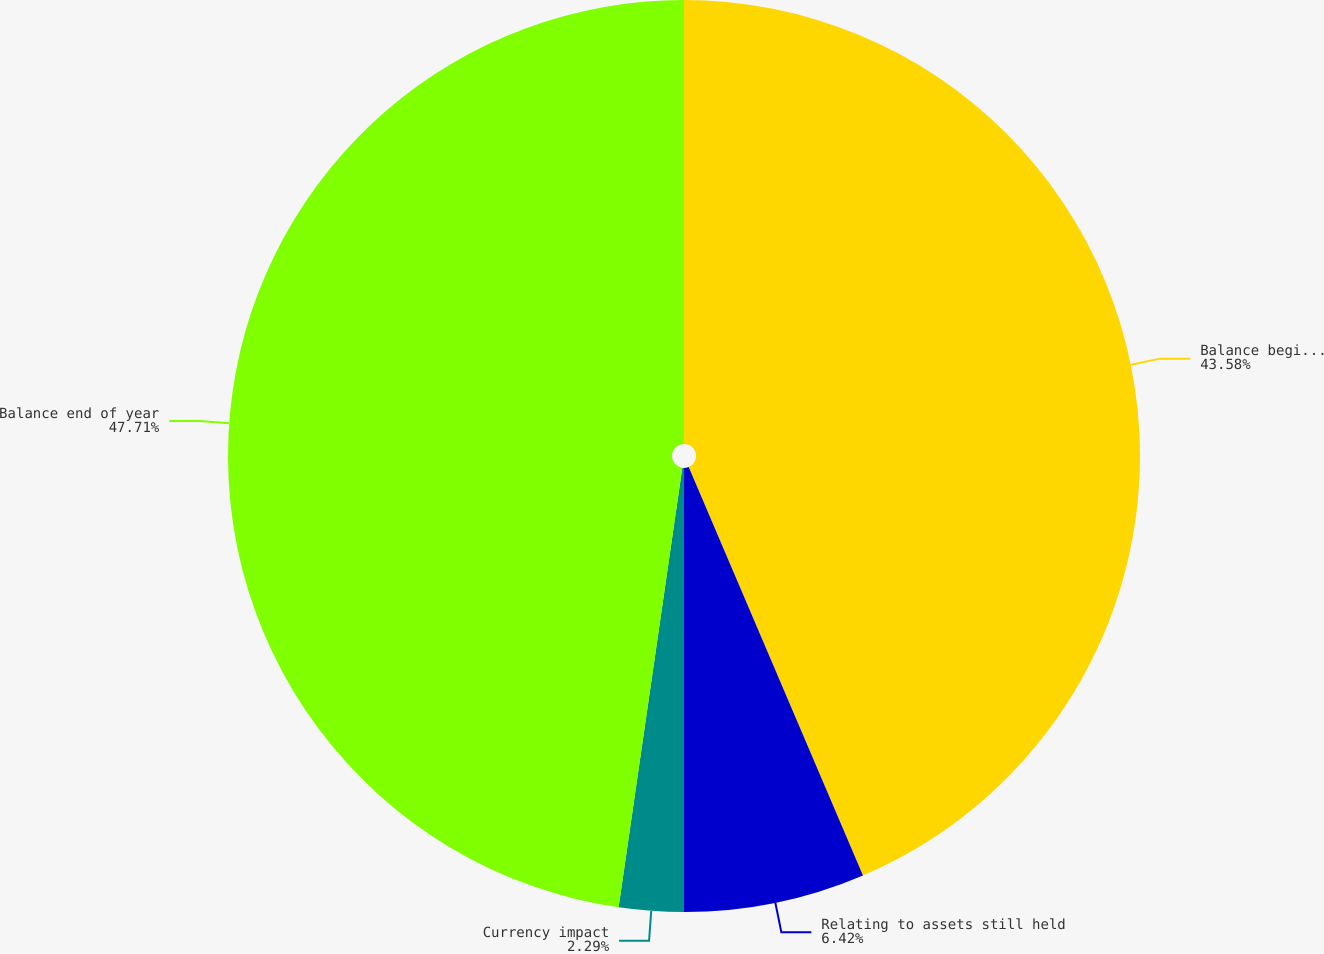Convert chart. <chart><loc_0><loc_0><loc_500><loc_500><pie_chart><fcel>Balance beginning of year<fcel>Relating to assets still held<fcel>Currency impact<fcel>Balance end of year<nl><fcel>43.58%<fcel>6.42%<fcel>2.29%<fcel>47.71%<nl></chart> 